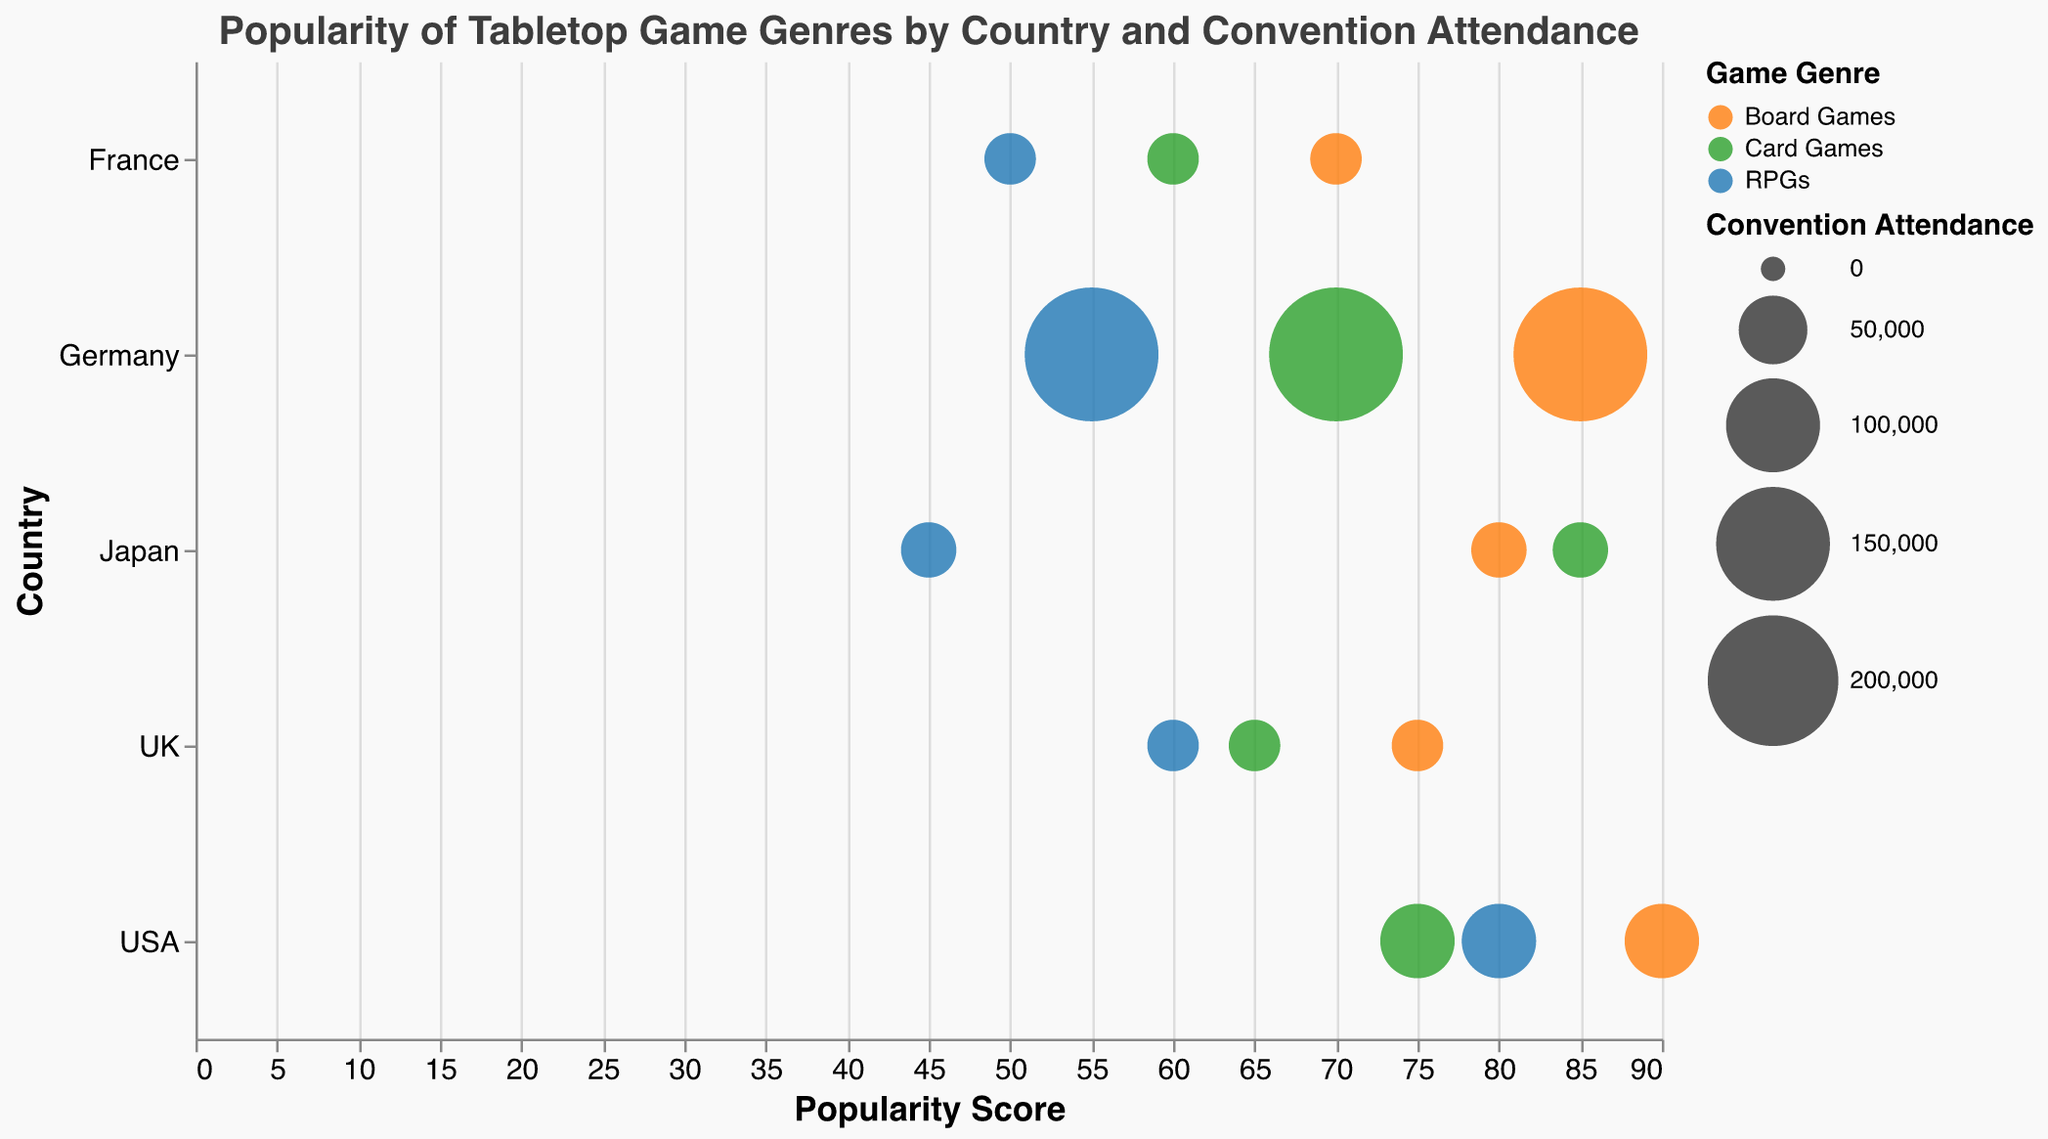What is the most popular genre of tabletop games in Germany at Essen Spiel? The data shows three genres: Board Games (85), Card Games (70), and RPGs (55). The highest score among these is 85 for Board Games.
Answer: Board Games Which convention has the highest attendance? The chart shows bubbles of different sizes representing attendance. Essen Spiel in Germany has the largest bubbles with 210,000 attendees.
Answer: Essen Spiel Among RPGs, which country has the lowest popularity score? RPGs' popularity scores are 55 (Germany), 80 (USA), 45 (Japan), 60 (UK), 50 (France). The lowest is 45 in Japan.
Answer: Japan What's the average popularity score for Board Games across all countries? Popularity scores for Board Games are 85 (Germany), 90 (USA), 80 (Japan), 75 (UK), 70 (France). Sum these up (85+90+80+75+70 = 400) and divide by 5 (400/5).
Answer: 80 Which country has the most balanced popularity scores across all three game genres? Compare the differences among the popularity scores for each genre within each country. Germany: (85-70=15, 70-55=15), USA: (90-75=15, 80-75=5), Japan: (80-85=5, 85-45=40), UK: (75-65=10, 65-60=5), France: (70-60=10, 60-50=10). USA has the lowest differences (15, 5).
Answer: USA In which country is Card Games more popular than Board Games? Compare the popularity scores for Board Games and Card Games in each country. Card Games scores higher in Japan (85 > 80).
Answer: Japan Which genre has the highest average popularity score? Calculate the average popularity for each genre. Board Games: (85+90+80+75+70)/5 = 80, Card Games: (70+75+85+65+60)/5 = 71, RPGs: (55+80+45+60+50)/5 = 58. Board Games have the highest average of 80.
Answer: Board Games What is the attendance difference between Essen Spiel and Gen Con? Compare the attendance figures: Essen Spiel (210,000) and Gen Con (60,000). The difference is 210,000 - 60,000 = 150,000.
Answer: 150,000 Which genre in the USA has the highest popularity score at Gen Con? USA's popularity scores for each genre at Gen Con are Board Games (90), Card Games (75), RPGs (80). The highest is 90 for Board Games.
Answer: Board Games How does the popularity of RPGs in the UK compare to that in France? The popularity of RPGs in the UK is 60, while in France it is 50. The UK has a higher popularity score by 10.
Answer: Higher by 10 